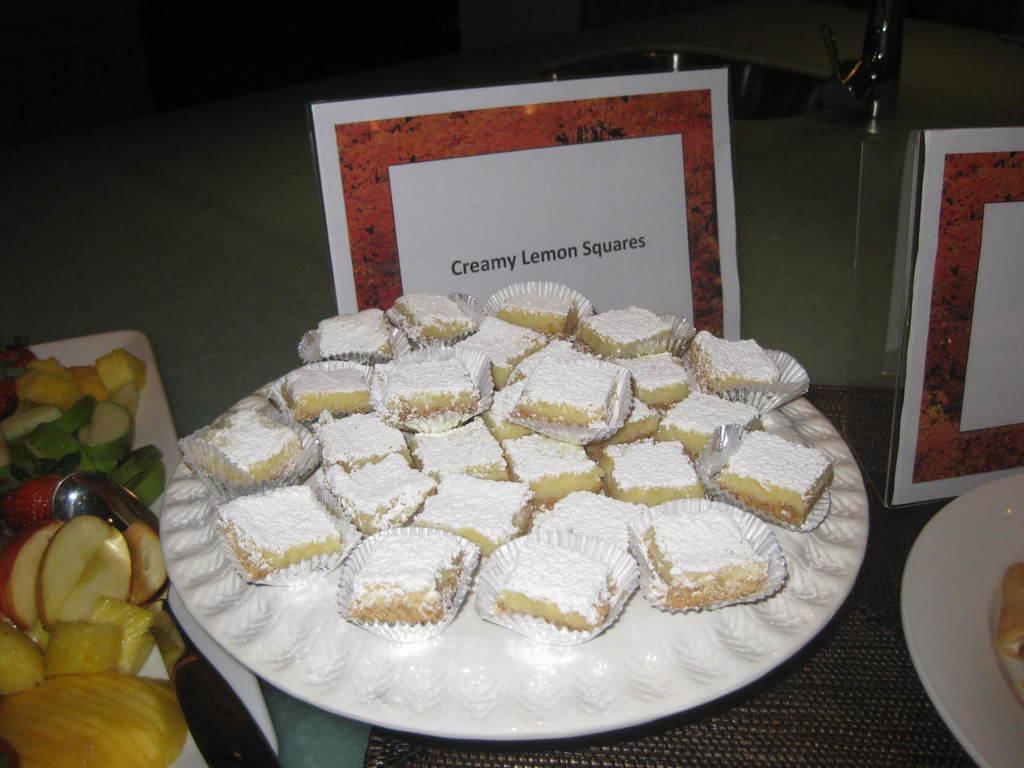Describe this image in one or two sentences. In the center of the image, we can see sweets on the plate and on the left, there are fruits and we can see a spoon on the plate and there are boards, a sink and a tap and we can see an other plate on the right, containing food and there is a mat. 